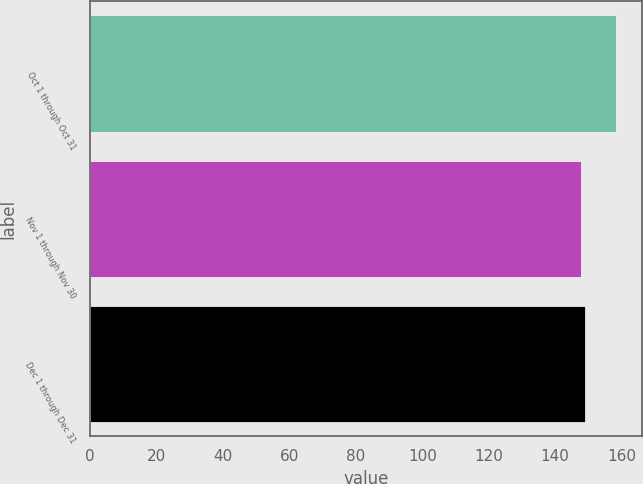Convert chart. <chart><loc_0><loc_0><loc_500><loc_500><bar_chart><fcel>Oct 1 through Oct 31<fcel>Nov 1 through Nov 30<fcel>Dec 1 through Dec 31<nl><fcel>158.2<fcel>147.91<fcel>148.94<nl></chart> 